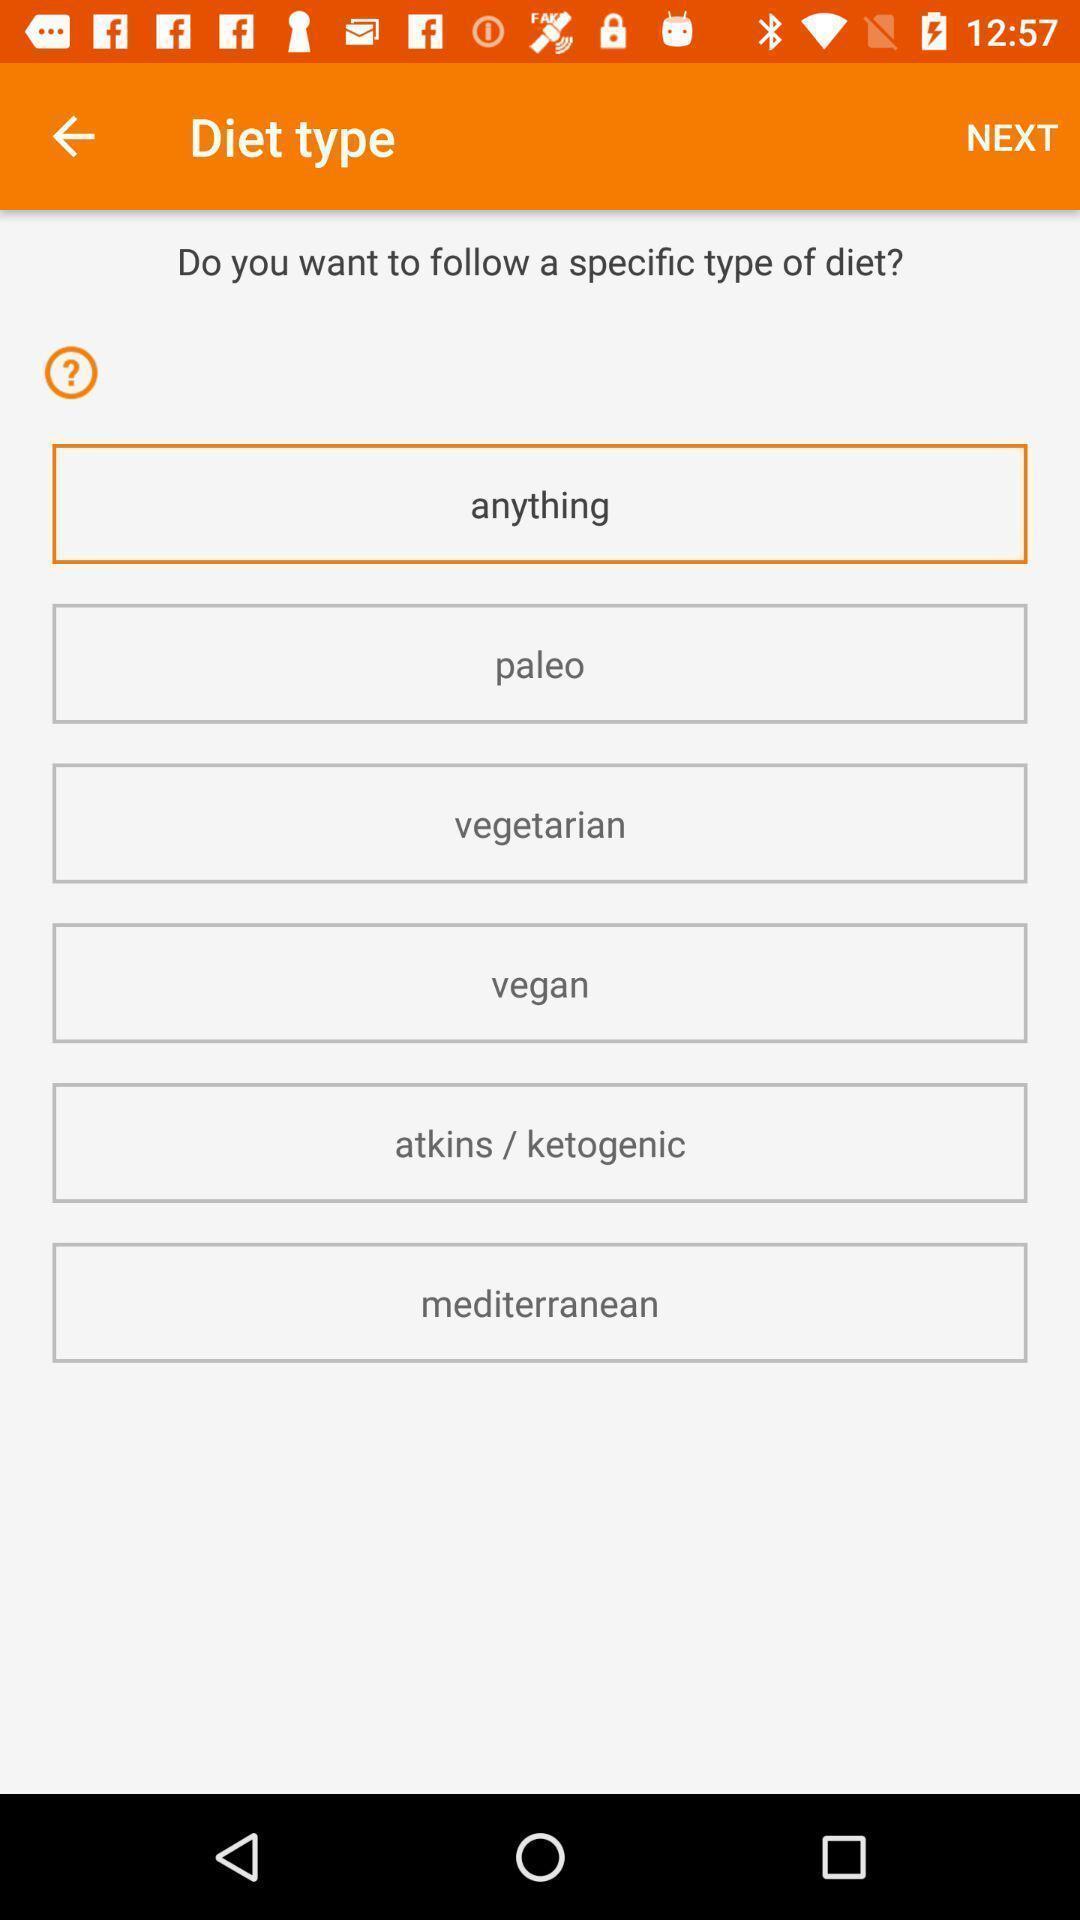Explain what's happening in this screen capture. Screen displaying types of diet. 